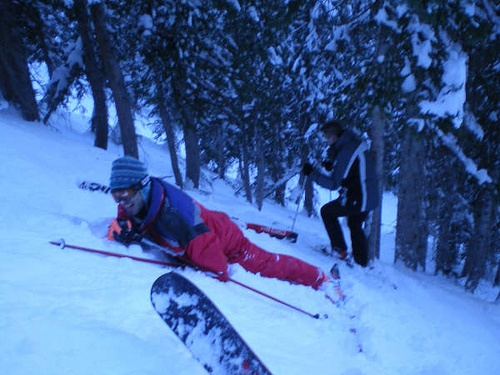Describe the objects in this image and their specific colors. I can see people in black, purple, navy, and darkblue tones, people in black, navy, blue, and lightblue tones, snowboard in black, lightblue, navy, blue, and darkblue tones, skis in black, lightblue, and blue tones, and skis in black, blue, gray, and navy tones in this image. 